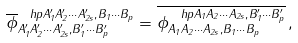Convert formula to latex. <formula><loc_0><loc_0><loc_500><loc_500>\overline { \phi } _ { A _ { 1 } ^ { \prime } A _ { 2 } ^ { \prime } \cdots A _ { 2 s } ^ { \prime } , B _ { 1 } ^ { \prime } \cdots B _ { p } ^ { \prime } } ^ { \ h p { A _ { 1 } ^ { \prime } A _ { 2 } ^ { \prime } \cdots A _ { 2 s } ^ { \prime } , } B _ { 1 } \cdots B _ { p } } = \overline { \phi _ { A _ { 1 } A _ { 2 } \cdots A _ { 2 s } , B _ { 1 } \cdots B _ { p } } ^ { \ h p { A _ { 1 } A _ { 2 } \cdots A _ { 2 s } , } B _ { 1 } ^ { \prime } \cdots B _ { p } ^ { \prime } } } \, ,</formula> 